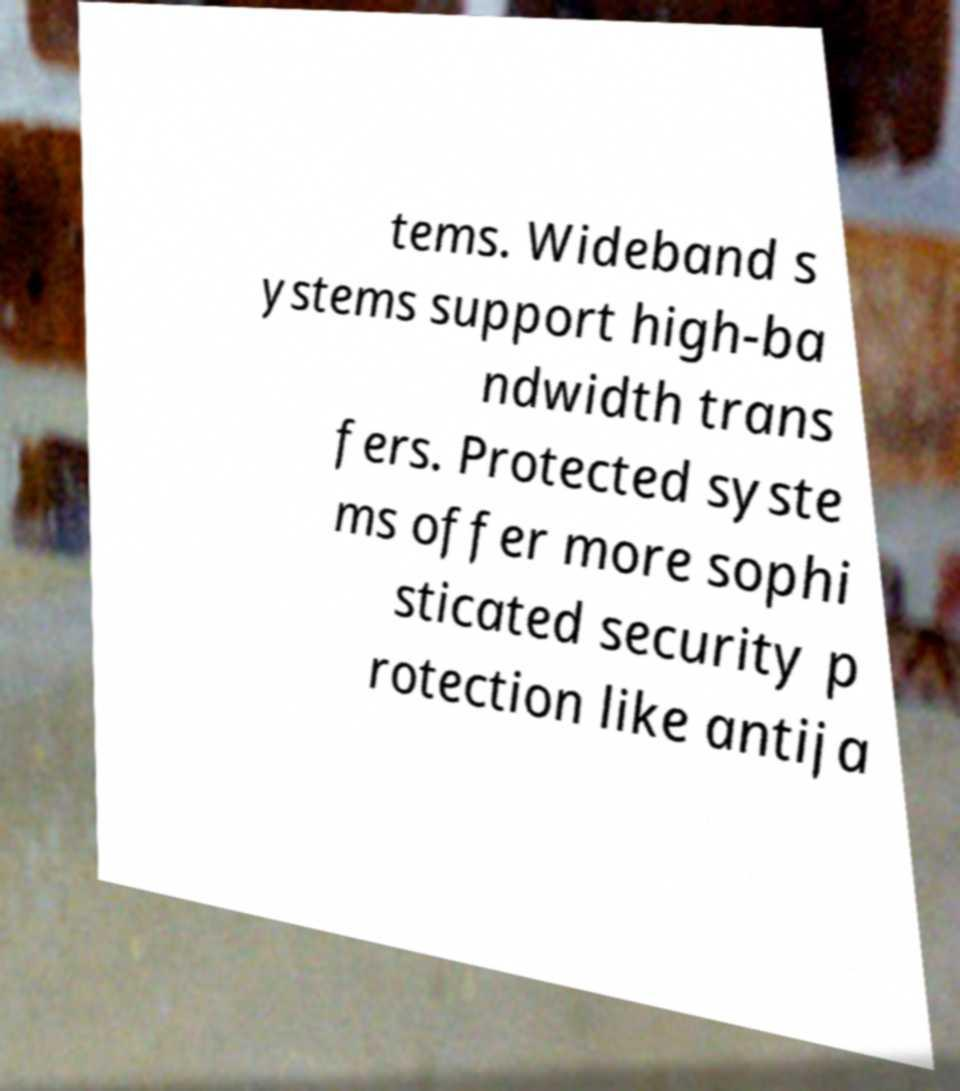What messages or text are displayed in this image? I need them in a readable, typed format. tems. Wideband s ystems support high-ba ndwidth trans fers. Protected syste ms offer more sophi sticated security p rotection like antija 